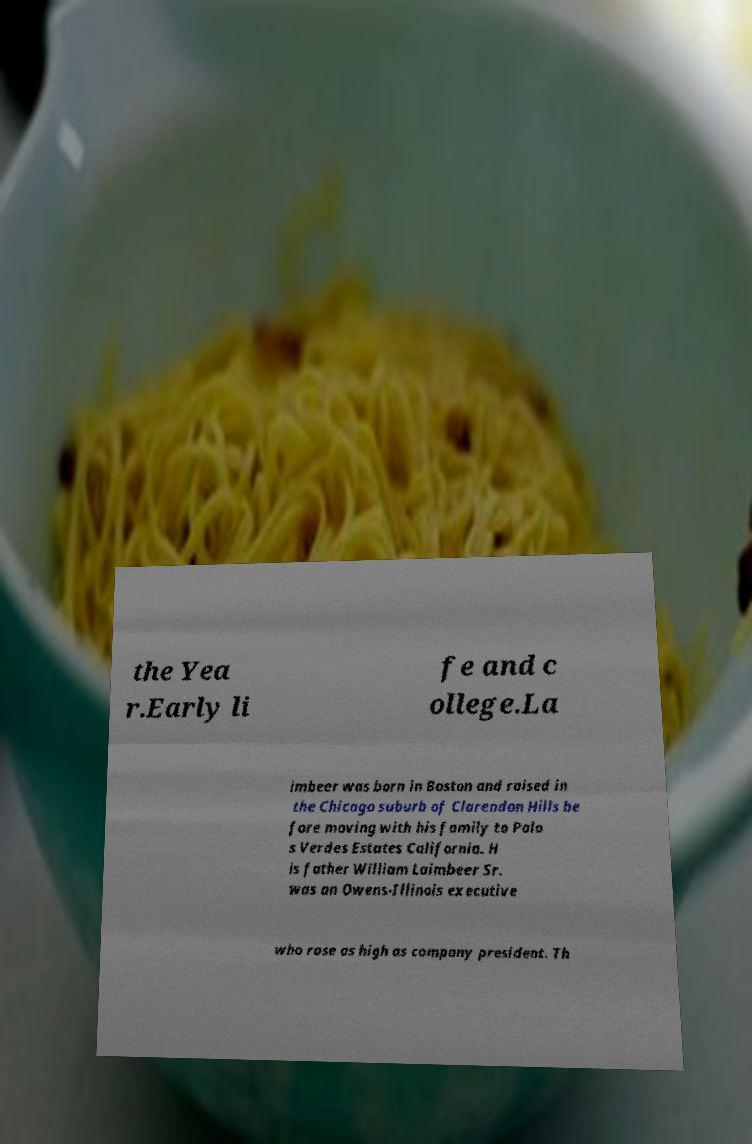Could you assist in decoding the text presented in this image and type it out clearly? the Yea r.Early li fe and c ollege.La imbeer was born in Boston and raised in the Chicago suburb of Clarendon Hills be fore moving with his family to Palo s Verdes Estates California. H is father William Laimbeer Sr. was an Owens-Illinois executive who rose as high as company president. Th 